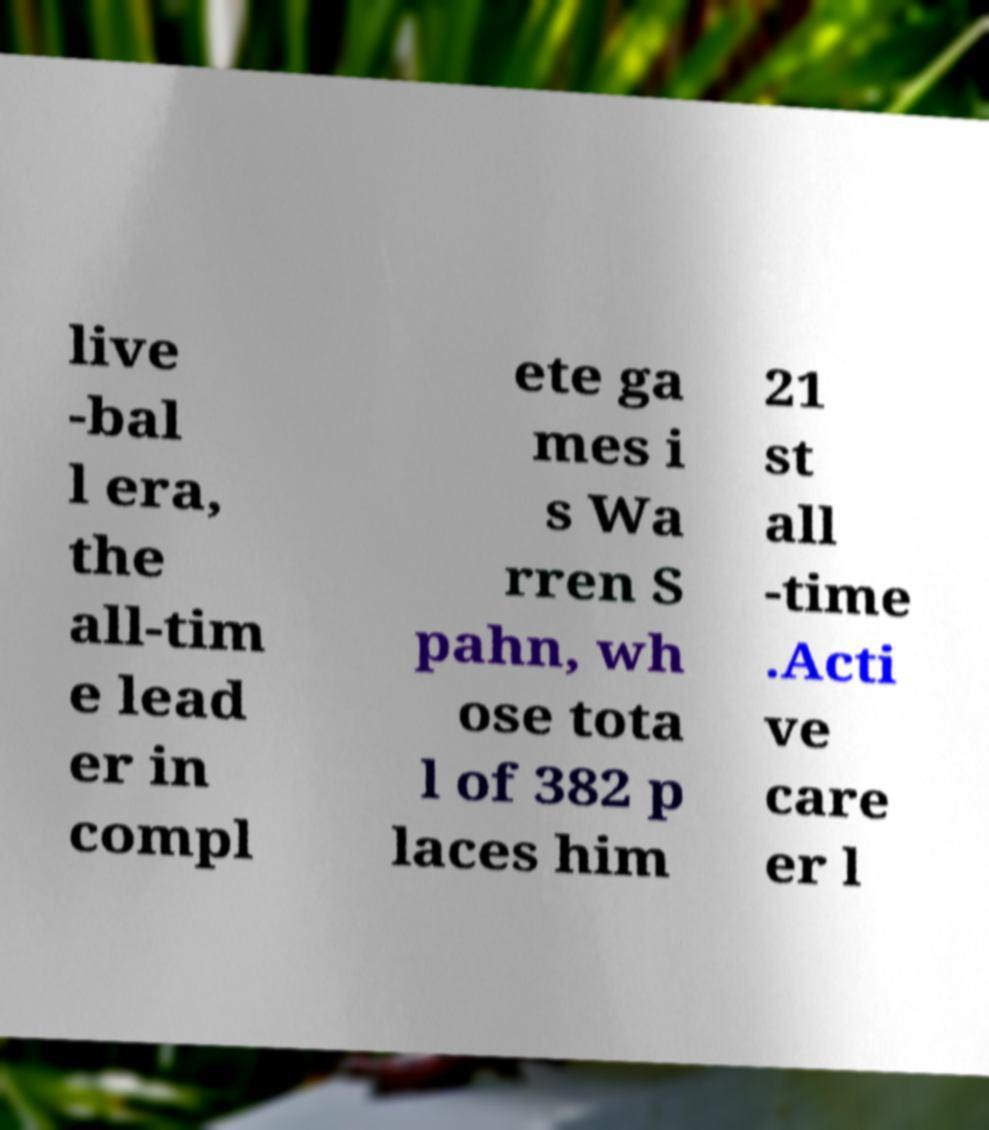I need the written content from this picture converted into text. Can you do that? live -bal l era, the all-tim e lead er in compl ete ga mes i s Wa rren S pahn, wh ose tota l of 382 p laces him 21 st all -time .Acti ve care er l 